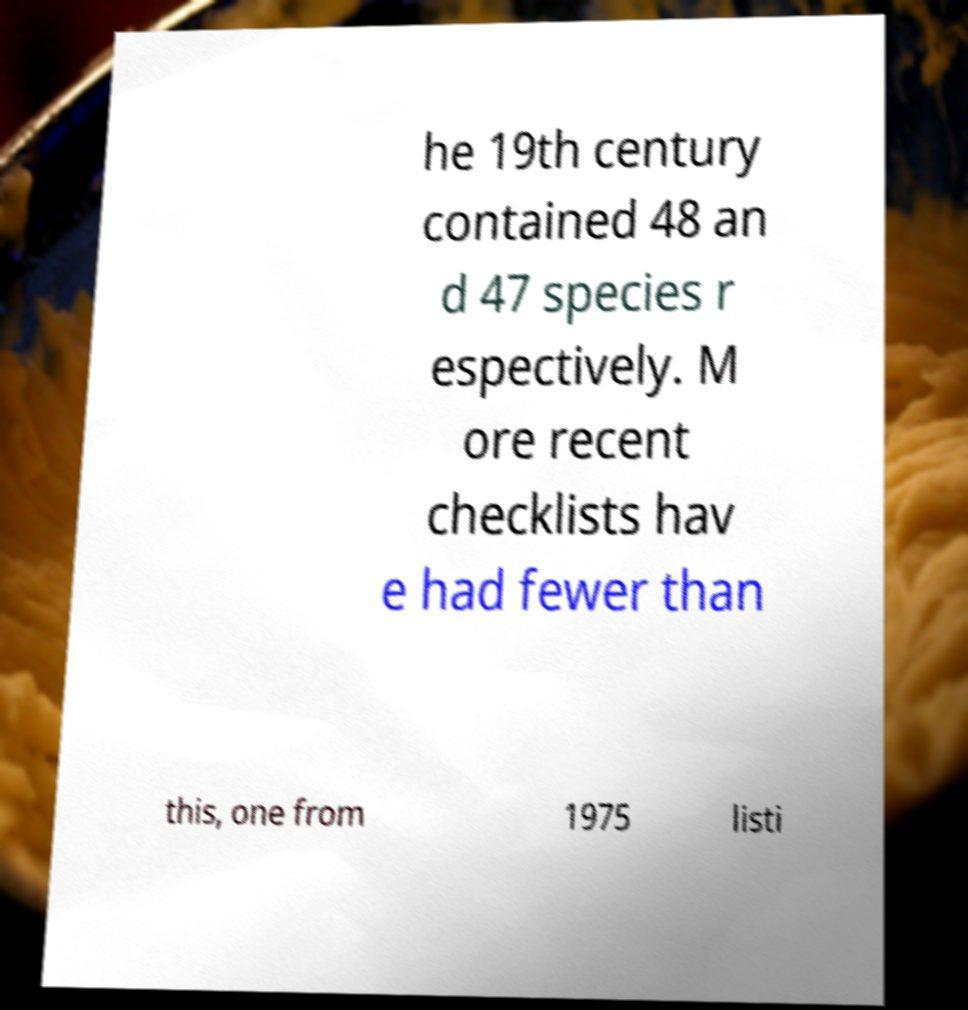There's text embedded in this image that I need extracted. Can you transcribe it verbatim? he 19th century contained 48 an d 47 species r espectively. M ore recent checklists hav e had fewer than this, one from 1975 listi 